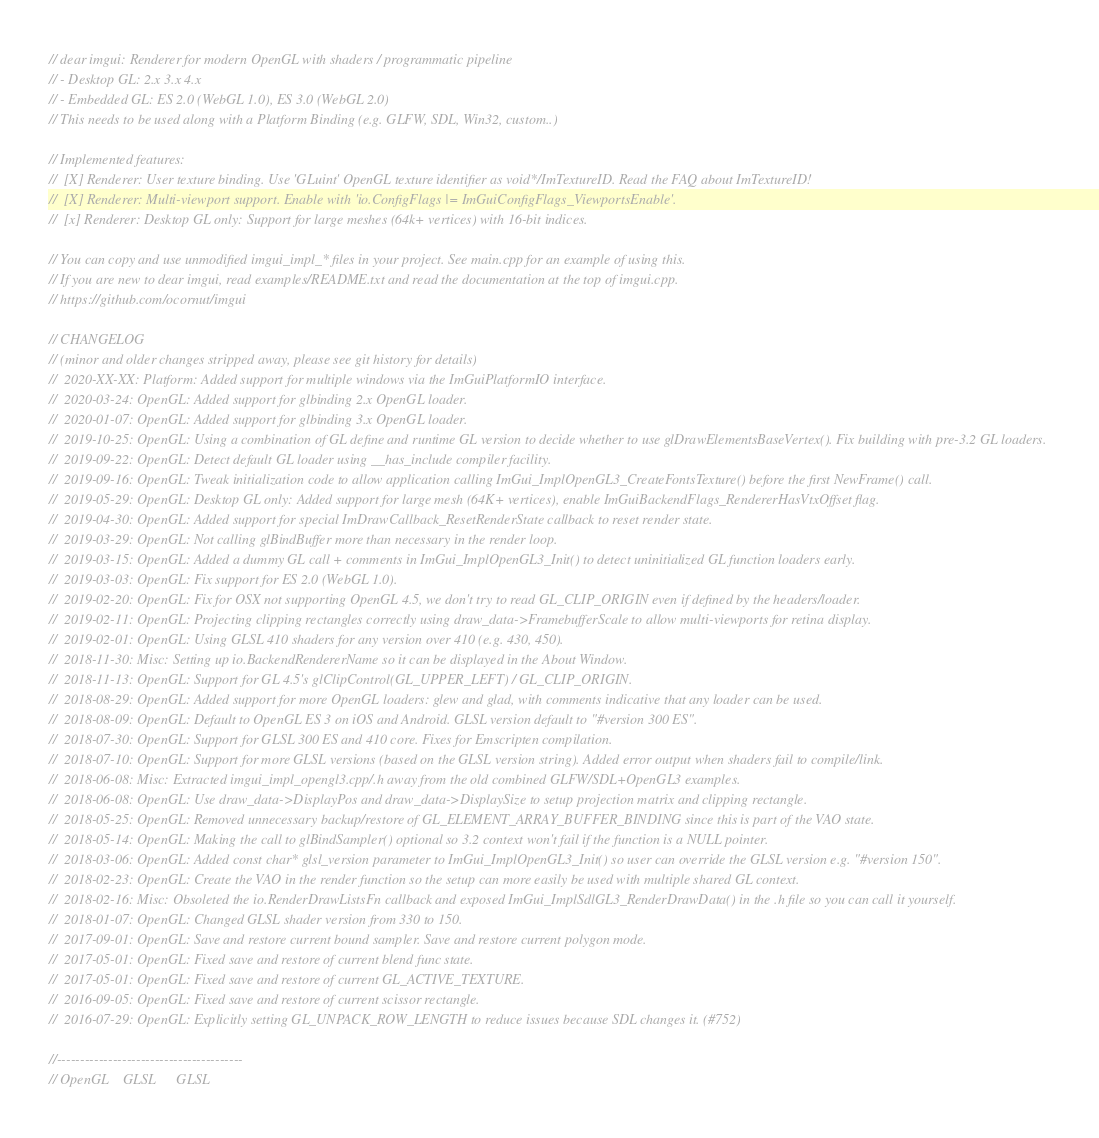<code> <loc_0><loc_0><loc_500><loc_500><_C++_>// dear imgui: Renderer for modern OpenGL with shaders / programmatic pipeline
// - Desktop GL: 2.x 3.x 4.x
// - Embedded GL: ES 2.0 (WebGL 1.0), ES 3.0 (WebGL 2.0)
// This needs to be used along with a Platform Binding (e.g. GLFW, SDL, Win32, custom..)

// Implemented features:
//  [X] Renderer: User texture binding. Use 'GLuint' OpenGL texture identifier as void*/ImTextureID. Read the FAQ about ImTextureID!
//  [X] Renderer: Multi-viewport support. Enable with 'io.ConfigFlags |= ImGuiConfigFlags_ViewportsEnable'.
//  [x] Renderer: Desktop GL only: Support for large meshes (64k+ vertices) with 16-bit indices.

// You can copy and use unmodified imgui_impl_* files in your project. See main.cpp for an example of using this.
// If you are new to dear imgui, read examples/README.txt and read the documentation at the top of imgui.cpp.
// https://github.com/ocornut/imgui

// CHANGELOG
// (minor and older changes stripped away, please see git history for details)
//  2020-XX-XX: Platform: Added support for multiple windows via the ImGuiPlatformIO interface.
//  2020-03-24: OpenGL: Added support for glbinding 2.x OpenGL loader.
//  2020-01-07: OpenGL: Added support for glbinding 3.x OpenGL loader.
//  2019-10-25: OpenGL: Using a combination of GL define and runtime GL version to decide whether to use glDrawElementsBaseVertex(). Fix building with pre-3.2 GL loaders.
//  2019-09-22: OpenGL: Detect default GL loader using __has_include compiler facility.
//  2019-09-16: OpenGL: Tweak initialization code to allow application calling ImGui_ImplOpenGL3_CreateFontsTexture() before the first NewFrame() call.
//  2019-05-29: OpenGL: Desktop GL only: Added support for large mesh (64K+ vertices), enable ImGuiBackendFlags_RendererHasVtxOffset flag.
//  2019-04-30: OpenGL: Added support for special ImDrawCallback_ResetRenderState callback to reset render state.
//  2019-03-29: OpenGL: Not calling glBindBuffer more than necessary in the render loop.
//  2019-03-15: OpenGL: Added a dummy GL call + comments in ImGui_ImplOpenGL3_Init() to detect uninitialized GL function loaders early.
//  2019-03-03: OpenGL: Fix support for ES 2.0 (WebGL 1.0).
//  2019-02-20: OpenGL: Fix for OSX not supporting OpenGL 4.5, we don't try to read GL_CLIP_ORIGIN even if defined by the headers/loader.
//  2019-02-11: OpenGL: Projecting clipping rectangles correctly using draw_data->FramebufferScale to allow multi-viewports for retina display.
//  2019-02-01: OpenGL: Using GLSL 410 shaders for any version over 410 (e.g. 430, 450).
//  2018-11-30: Misc: Setting up io.BackendRendererName so it can be displayed in the About Window.
//  2018-11-13: OpenGL: Support for GL 4.5's glClipControl(GL_UPPER_LEFT) / GL_CLIP_ORIGIN.
//  2018-08-29: OpenGL: Added support for more OpenGL loaders: glew and glad, with comments indicative that any loader can be used.
//  2018-08-09: OpenGL: Default to OpenGL ES 3 on iOS and Android. GLSL version default to "#version 300 ES".
//  2018-07-30: OpenGL: Support for GLSL 300 ES and 410 core. Fixes for Emscripten compilation.
//  2018-07-10: OpenGL: Support for more GLSL versions (based on the GLSL version string). Added error output when shaders fail to compile/link.
//  2018-06-08: Misc: Extracted imgui_impl_opengl3.cpp/.h away from the old combined GLFW/SDL+OpenGL3 examples.
//  2018-06-08: OpenGL: Use draw_data->DisplayPos and draw_data->DisplaySize to setup projection matrix and clipping rectangle.
//  2018-05-25: OpenGL: Removed unnecessary backup/restore of GL_ELEMENT_ARRAY_BUFFER_BINDING since this is part of the VAO state.
//  2018-05-14: OpenGL: Making the call to glBindSampler() optional so 3.2 context won't fail if the function is a NULL pointer.
//  2018-03-06: OpenGL: Added const char* glsl_version parameter to ImGui_ImplOpenGL3_Init() so user can override the GLSL version e.g. "#version 150".
//  2018-02-23: OpenGL: Create the VAO in the render function so the setup can more easily be used with multiple shared GL context.
//  2018-02-16: Misc: Obsoleted the io.RenderDrawListsFn callback and exposed ImGui_ImplSdlGL3_RenderDrawData() in the .h file so you can call it yourself.
//  2018-01-07: OpenGL: Changed GLSL shader version from 330 to 150.
//  2017-09-01: OpenGL: Save and restore current bound sampler. Save and restore current polygon mode.
//  2017-05-01: OpenGL: Fixed save and restore of current blend func state.
//  2017-05-01: OpenGL: Fixed save and restore of current GL_ACTIVE_TEXTURE.
//  2016-09-05: OpenGL: Fixed save and restore of current scissor rectangle.
//  2016-07-29: OpenGL: Explicitly setting GL_UNPACK_ROW_LENGTH to reduce issues because SDL changes it. (#752)

//----------------------------------------
// OpenGL    GLSL      GLSL</code> 